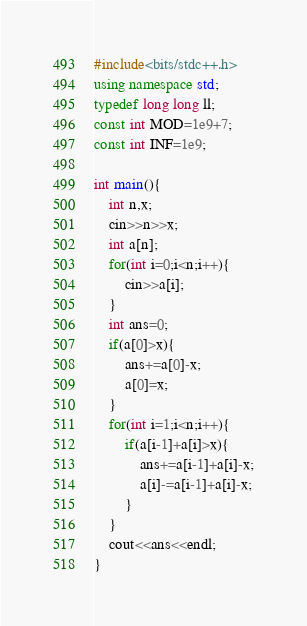<code> <loc_0><loc_0><loc_500><loc_500><_C++_>#include<bits/stdc++.h>
using namespace std;
typedef long long ll;
const int MOD=1e9+7;
const int INF=1e9;

int main(){
    int n,x;
    cin>>n>>x;
    int a[n];
    for(int i=0;i<n;i++){
        cin>>a[i];
    }
    int ans=0;
    if(a[0]>x){
        ans+=a[0]-x;
        a[0]=x;
    }
    for(int i=1;i<n;i++){
        if(a[i-1]+a[i]>x){
            ans+=a[i-1]+a[i]-x;
            a[i]-=a[i-1]+a[i]-x;
        }
    }
    cout<<ans<<endl;
}
</code> 